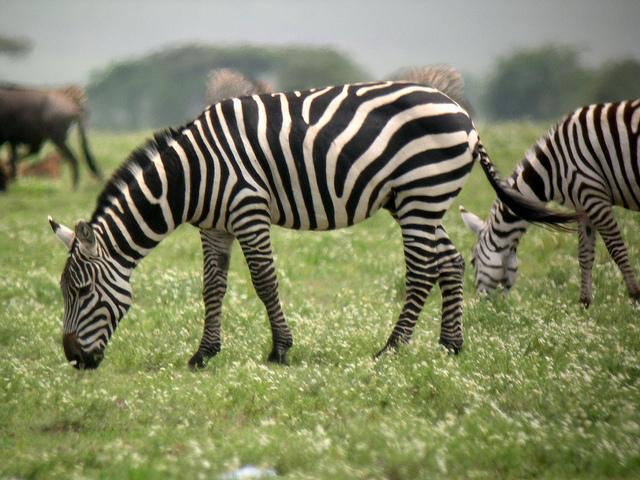How many zebras are there?
Short answer required. 2. Are the zebras chasing each other?
Short answer required. No. Are the zebras eating?
Give a very brief answer. Yes. 